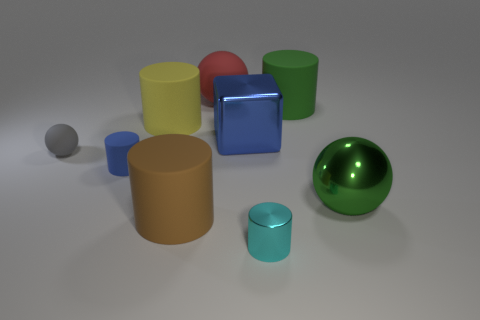The small cylinder in front of the ball that is in front of the tiny blue cylinder is what color?
Keep it short and to the point. Cyan. There is a object that is the same color as the large block; what is its size?
Your answer should be compact. Small. How many blue blocks are behind the big cylinder that is in front of the large shiny object in front of the blue rubber object?
Give a very brief answer. 1. There is a big matte object on the right side of the large rubber sphere; is it the same shape as the small matte object on the left side of the blue rubber thing?
Provide a succinct answer. No. What number of things are either big matte spheres or large blue things?
Provide a succinct answer. 2. There is a small cylinder that is in front of the rubber object in front of the tiny blue thing; what is its material?
Offer a terse response. Metal. Is there another ball that has the same color as the small ball?
Provide a short and direct response. No. There is a metallic block that is the same size as the green metallic sphere; what color is it?
Keep it short and to the point. Blue. What material is the green object on the left side of the big sphere that is in front of the sphere behind the green cylinder?
Your response must be concise. Rubber. Does the big metal sphere have the same color as the large rubber object that is in front of the small gray ball?
Offer a very short reply. No. 